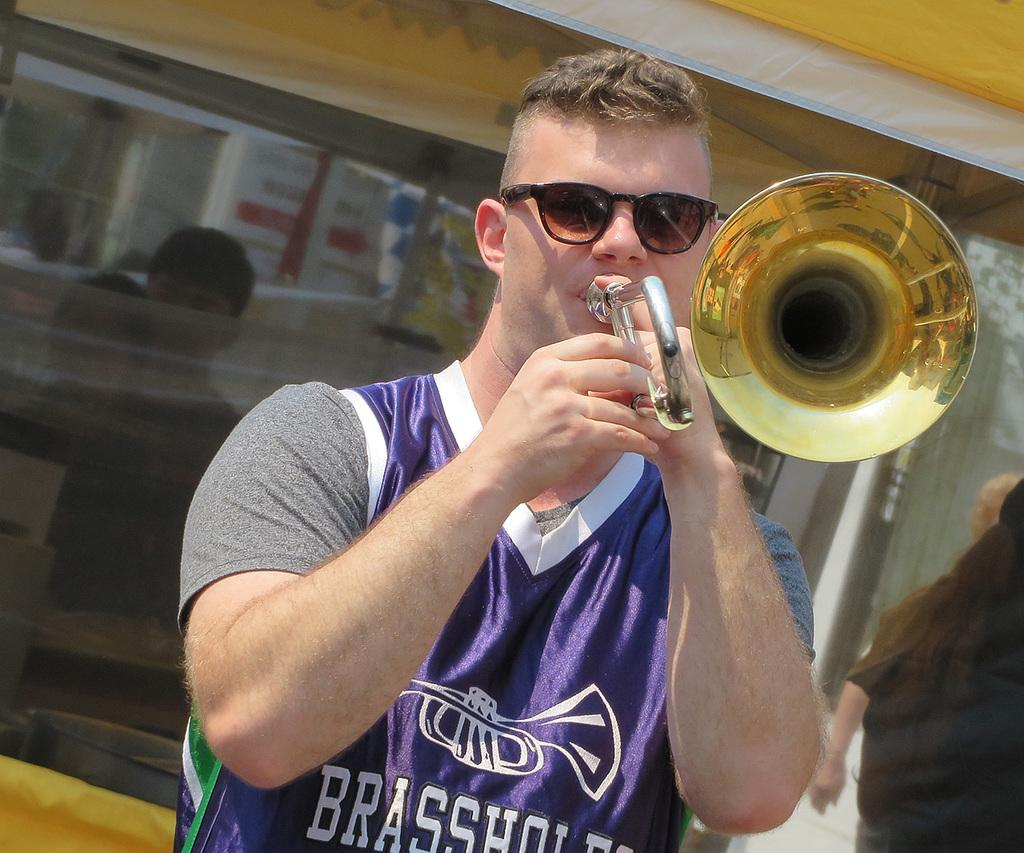What is the man in the image doing? The man is playing a musical instrument in the image. What can be seen in the background of the image? There is a reflection of people and a building in the background of the image. What type of worm can be seen pulling a carriage in the image? There is no worm or carriage present in the image. What is the man's interest in the musical instrument he is playing? The image does not provide information about the man's interest in the musical instrument he is playing. 